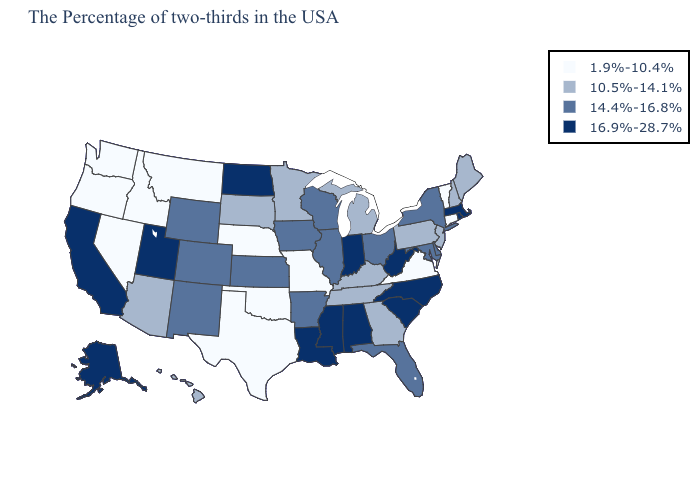What is the value of Wisconsin?
Answer briefly. 14.4%-16.8%. Name the states that have a value in the range 1.9%-10.4%?
Quick response, please. Vermont, Connecticut, Virginia, Missouri, Nebraska, Oklahoma, Texas, Montana, Idaho, Nevada, Washington, Oregon. Name the states that have a value in the range 10.5%-14.1%?
Keep it brief. Maine, New Hampshire, New Jersey, Pennsylvania, Georgia, Michigan, Kentucky, Tennessee, Minnesota, South Dakota, Arizona, Hawaii. Does Rhode Island have the same value as Wyoming?
Give a very brief answer. No. How many symbols are there in the legend?
Answer briefly. 4. What is the value of Vermont?
Give a very brief answer. 1.9%-10.4%. What is the value of Mississippi?
Give a very brief answer. 16.9%-28.7%. Does Hawaii have the highest value in the USA?
Be succinct. No. What is the value of Arkansas?
Give a very brief answer. 14.4%-16.8%. Which states hav the highest value in the Northeast?
Answer briefly. Massachusetts, Rhode Island. Name the states that have a value in the range 1.9%-10.4%?
Quick response, please. Vermont, Connecticut, Virginia, Missouri, Nebraska, Oklahoma, Texas, Montana, Idaho, Nevada, Washington, Oregon. What is the value of Mississippi?
Give a very brief answer. 16.9%-28.7%. Does Alaska have the lowest value in the West?
Be succinct. No. Name the states that have a value in the range 10.5%-14.1%?
Quick response, please. Maine, New Hampshire, New Jersey, Pennsylvania, Georgia, Michigan, Kentucky, Tennessee, Minnesota, South Dakota, Arizona, Hawaii. What is the value of New York?
Quick response, please. 14.4%-16.8%. 